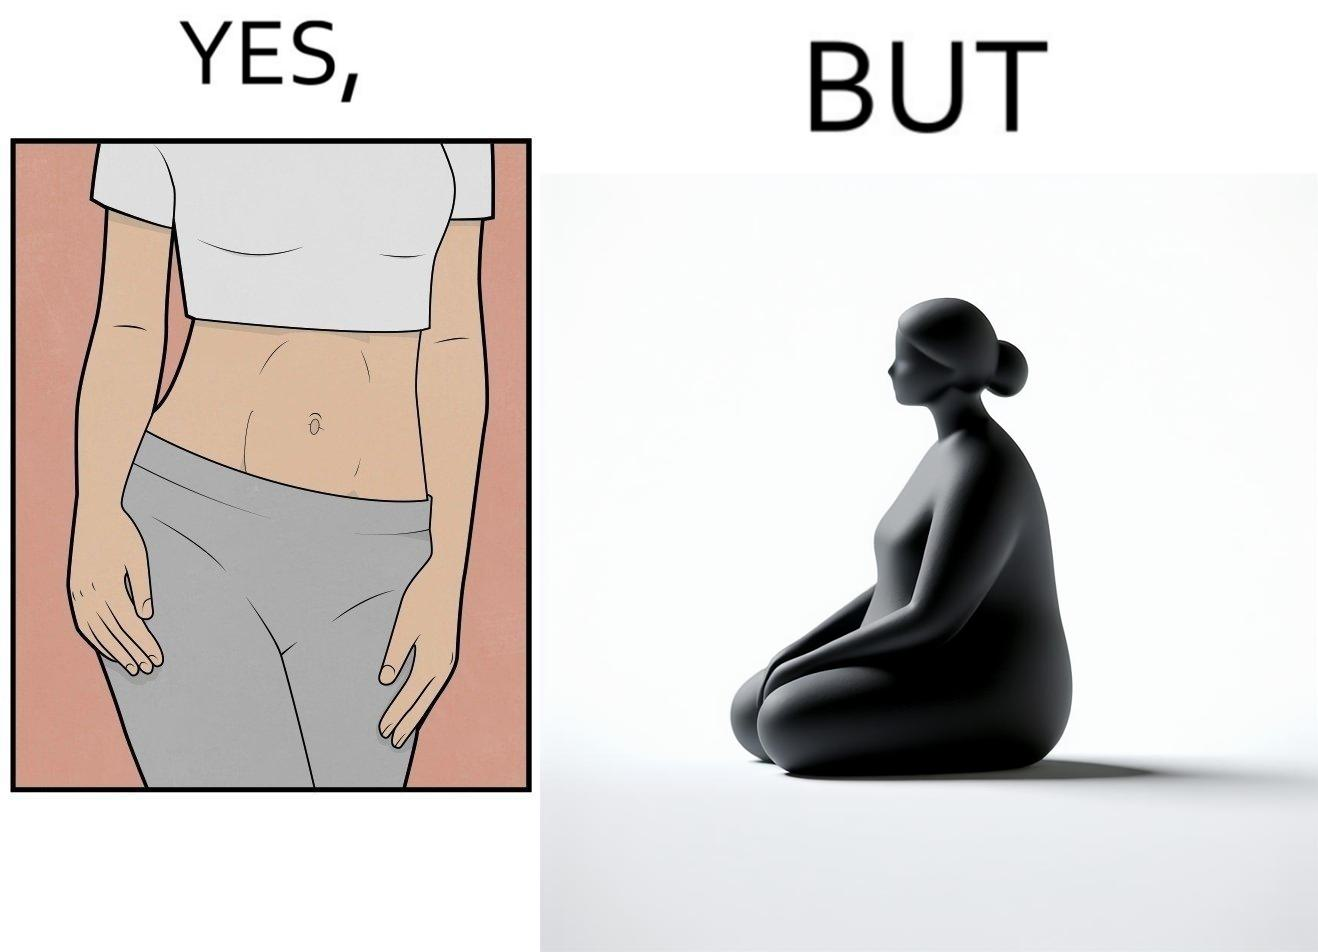Describe the contrast between the left and right parts of this image. In the left part of the image: a slim woman In the right part of the image: An apparently chubby woman sitting 